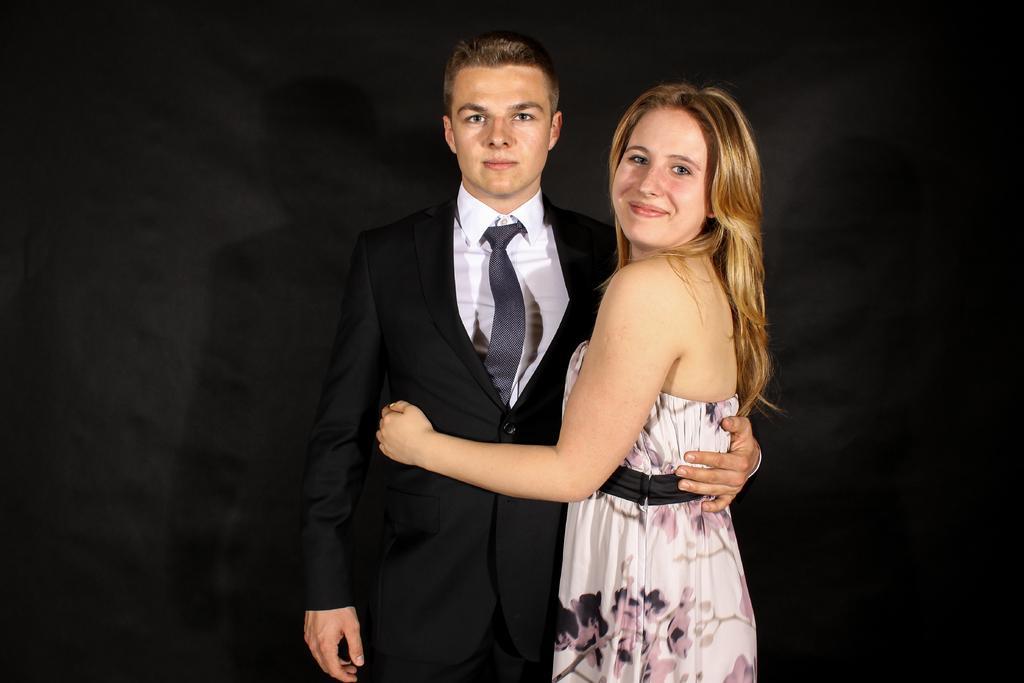Can you describe this image briefly? In the picture I can see a man and a woman are standing together and smiling. The man is wearing a black color coat, a white color shirt and a tie. The background of the image is dark in color. 